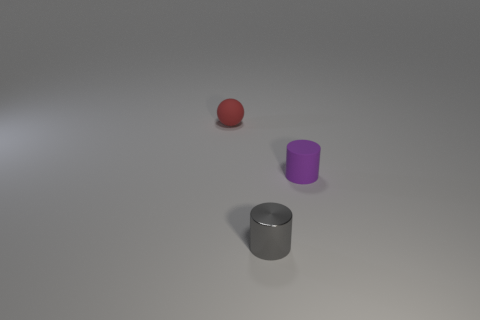The purple rubber thing that is the same size as the red matte ball is what shape?
Make the answer very short. Cylinder. Is there a small cylinder that has the same color as the shiny object?
Your response must be concise. No. What is the shape of the tiny rubber object that is left of the purple matte cylinder?
Your answer should be compact. Sphere. The sphere has what color?
Give a very brief answer. Red. What color is the thing that is made of the same material as the small purple cylinder?
Your response must be concise. Red. How many other small things have the same material as the small red object?
Your response must be concise. 1. How many purple things are on the right side of the tiny purple cylinder?
Ensure brevity in your answer.  0. Is the material of the cylinder in front of the small purple rubber cylinder the same as the object that is behind the purple cylinder?
Provide a short and direct response. No. Is the number of small shiny cylinders that are in front of the tiny metal cylinder greater than the number of tiny red rubber objects to the right of the matte cylinder?
Your response must be concise. No. Are there any other things that have the same shape as the red rubber thing?
Keep it short and to the point. No. 